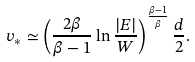<formula> <loc_0><loc_0><loc_500><loc_500>v _ { \ast } \simeq \left ( \frac { 2 \beta } { \beta - 1 } \ln \frac { | E | } { W } \right ) ^ { \frac { \beta - 1 } { \beta } } \frac { d } { 2 } .</formula> 